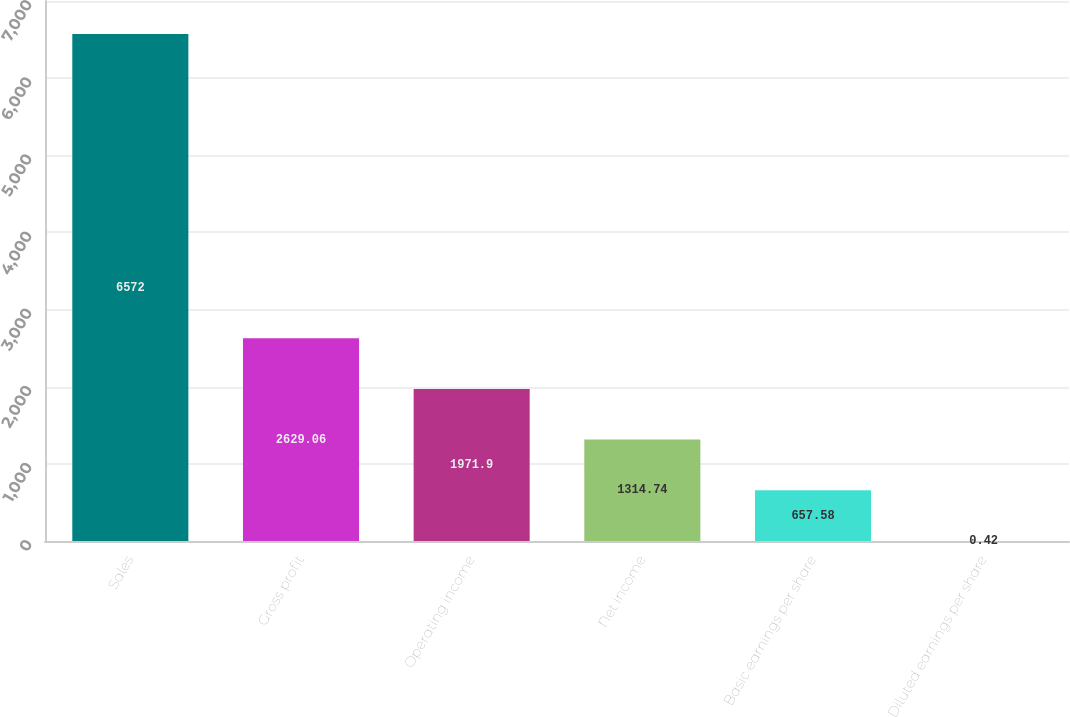Convert chart. <chart><loc_0><loc_0><loc_500><loc_500><bar_chart><fcel>Sales<fcel>Gross profit<fcel>Operating income<fcel>Net income<fcel>Basic earnings per share<fcel>Diluted earnings per share<nl><fcel>6572<fcel>2629.06<fcel>1971.9<fcel>1314.74<fcel>657.58<fcel>0.42<nl></chart> 